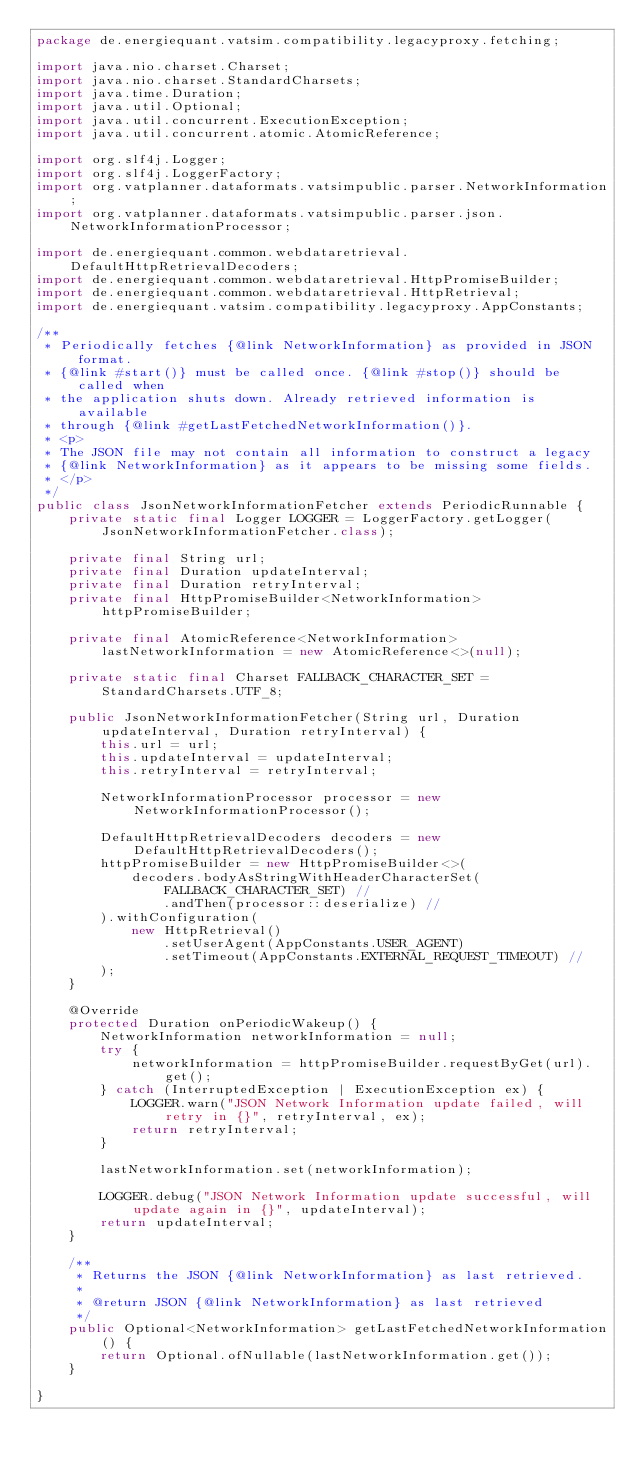<code> <loc_0><loc_0><loc_500><loc_500><_Java_>package de.energiequant.vatsim.compatibility.legacyproxy.fetching;

import java.nio.charset.Charset;
import java.nio.charset.StandardCharsets;
import java.time.Duration;
import java.util.Optional;
import java.util.concurrent.ExecutionException;
import java.util.concurrent.atomic.AtomicReference;

import org.slf4j.Logger;
import org.slf4j.LoggerFactory;
import org.vatplanner.dataformats.vatsimpublic.parser.NetworkInformation;
import org.vatplanner.dataformats.vatsimpublic.parser.json.NetworkInformationProcessor;

import de.energiequant.common.webdataretrieval.DefaultHttpRetrievalDecoders;
import de.energiequant.common.webdataretrieval.HttpPromiseBuilder;
import de.energiequant.common.webdataretrieval.HttpRetrieval;
import de.energiequant.vatsim.compatibility.legacyproxy.AppConstants;

/**
 * Periodically fetches {@link NetworkInformation} as provided in JSON format.
 * {@link #start()} must be called once. {@link #stop()} should be called when
 * the application shuts down. Already retrieved information is available
 * through {@link #getLastFetchedNetworkInformation()}.
 * <p>
 * The JSON file may not contain all information to construct a legacy
 * {@link NetworkInformation} as it appears to be missing some fields.
 * </p>
 */
public class JsonNetworkInformationFetcher extends PeriodicRunnable {
    private static final Logger LOGGER = LoggerFactory.getLogger(JsonNetworkInformationFetcher.class);

    private final String url;
    private final Duration updateInterval;
    private final Duration retryInterval;
    private final HttpPromiseBuilder<NetworkInformation> httpPromiseBuilder;

    private final AtomicReference<NetworkInformation> lastNetworkInformation = new AtomicReference<>(null);

    private static final Charset FALLBACK_CHARACTER_SET = StandardCharsets.UTF_8;

    public JsonNetworkInformationFetcher(String url, Duration updateInterval, Duration retryInterval) {
        this.url = url;
        this.updateInterval = updateInterval;
        this.retryInterval = retryInterval;

        NetworkInformationProcessor processor = new NetworkInformationProcessor();

        DefaultHttpRetrievalDecoders decoders = new DefaultHttpRetrievalDecoders();
        httpPromiseBuilder = new HttpPromiseBuilder<>(
            decoders.bodyAsStringWithHeaderCharacterSet(FALLBACK_CHARACTER_SET) //
                .andThen(processor::deserialize) //
        ).withConfiguration(
            new HttpRetrieval()
                .setUserAgent(AppConstants.USER_AGENT)
                .setTimeout(AppConstants.EXTERNAL_REQUEST_TIMEOUT) //
        );
    }

    @Override
    protected Duration onPeriodicWakeup() {
        NetworkInformation networkInformation = null;
        try {
            networkInformation = httpPromiseBuilder.requestByGet(url).get();
        } catch (InterruptedException | ExecutionException ex) {
            LOGGER.warn("JSON Network Information update failed, will retry in {}", retryInterval, ex);
            return retryInterval;
        }

        lastNetworkInformation.set(networkInformation);

        LOGGER.debug("JSON Network Information update successful, will update again in {}", updateInterval);
        return updateInterval;
    }

    /**
     * Returns the JSON {@link NetworkInformation} as last retrieved.
     * 
     * @return JSON {@link NetworkInformation} as last retrieved
     */
    public Optional<NetworkInformation> getLastFetchedNetworkInformation() {
        return Optional.ofNullable(lastNetworkInformation.get());
    }

}
</code> 